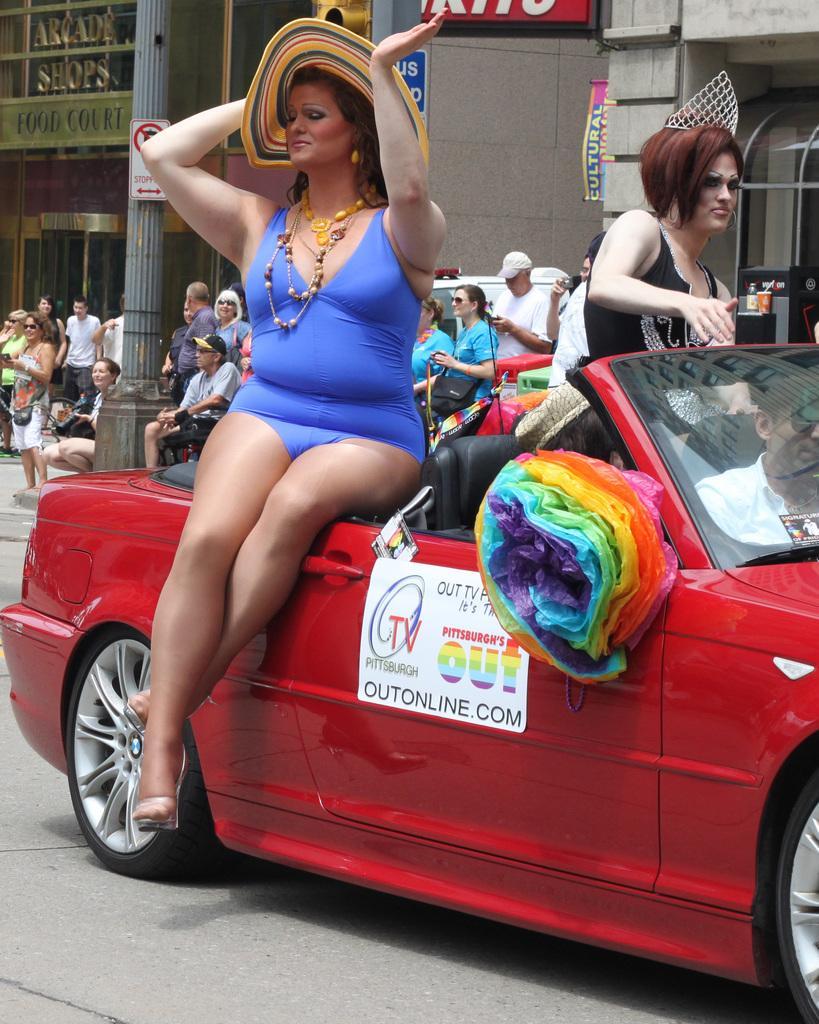In one or two sentences, can you explain what this image depicts? Here in the front we can see a woman sitting on a car and there are two other people in the car and behind them we can see a group of people standing and there are buildings present 